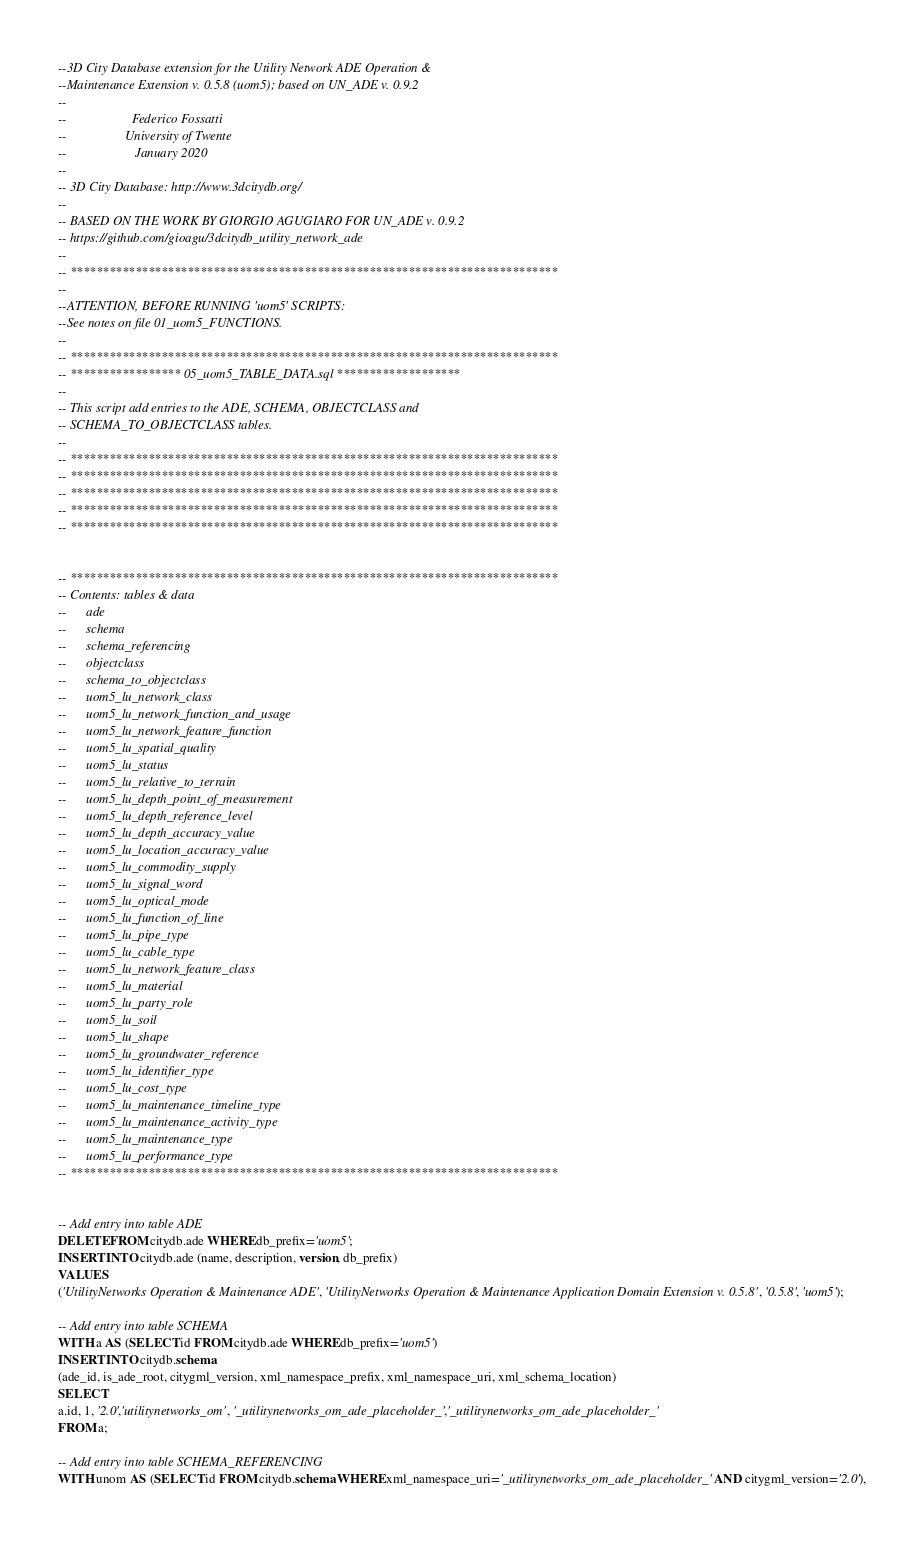Convert code to text. <code><loc_0><loc_0><loc_500><loc_500><_SQL_>--3D City Database extension for the Utility Network ADE Operation & 
--Maintenance Extension v. 0.5.8 (uom5); based on UN_ADE v. 0.9.2
--
--					  Federico Fossatti
--					University of Twente
--                     January 2020
--
-- 3D City Database: http://www.3dcitydb.org/ 
-- 
-- BASED ON THE WORK BY GIORGIO AGUGIARO FOR UN_ADE v. 0.9.2
-- https://github.com/gioagu/3dcitydb_utility_network_ade
--
-- ***************************************************************************
--
--ATTENTION, BEFORE RUNNING 'uom5' SCRIPTS:
--See notes on file 01_uom5_FUNCTIONS.
--
-- ***************************************************************************
-- ***************** 05_uom5_TABLE_DATA.sql *******************
--
-- This script add entries to the ADE, SCHEMA, OBJECTCLASS and
-- SCHEMA_TO_OBJECTCLASS tables.
--
-- ***************************************************************************
-- ***************************************************************************
-- ***************************************************************************
-- ***************************************************************************
-- ***************************************************************************


-- ***************************************************************************
-- Contents: tables & data
-- 		ade
-- 		schema
-- 		schema_referencing
-- 		objectclass
-- 		schema_to_objectclass
-- 		uom5_lu_network_class
-- 		uom5_lu_network_function_and_usage
-- 		uom5_lu_network_feature_function
-- 		uom5_lu_spatial_quality
-- 		uom5_lu_status
-- 		uom5_lu_relative_to_terrain
-- 		uom5_lu_depth_point_of_measurement
-- 		uom5_lu_depth_reference_level
-- 		uom5_lu_depth_accuracy_value
-- 		uom5_lu_location_accuracy_value
-- 		uom5_lu_commodity_supply
-- 		uom5_lu_signal_word
-- 		uom5_lu_optical_mode
-- 		uom5_lu_function_of_line
-- 		uom5_lu_pipe_type
-- 		uom5_lu_cable_type
-- 		uom5_lu_network_feature_class
-- 		uom5_lu_material
-- 		uom5_lu_party_role
-- 		uom5_lu_soil
-- 		uom5_lu_shape
-- 		uom5_lu_groundwater_reference
-- 		uom5_lu_identifier_type
-- 		uom5_lu_cost_type
-- 		uom5_lu_maintenance_timeline_type
-- 		uom5_lu_maintenance_activity_type
-- 		uom5_lu_maintenance_type
-- 		uom5_lu_performance_type
-- ***************************************************************************


-- Add entry into table ADE
DELETE FROM citydb.ade WHERE db_prefix='uom5'; 
INSERT INTO citydb.ade (name, description, version, db_prefix)
VALUES
('UtilityNetworks Operation & Maintenance ADE', 'UtilityNetworks Operation & Maintenance Application Domain Extension v. 0.5.8', '0.5.8', 'uom5');

-- Add entry into table SCHEMA
WITH a AS (SELECT id FROM citydb.ade WHERE db_prefix='uom5')
INSERT INTO citydb.schema
(ade_id, is_ade_root, citygml_version, xml_namespace_prefix, xml_namespace_uri, xml_schema_location)
SELECT
a.id, 1, '2.0','utilitynetworks_om', '_utilitynetworks_om_ade_placeholder_','_utilitynetworks_om_ade_placeholder_'
FROM a;

-- Add entry into table SCHEMA_REFERENCING
WITH unom AS (SELECT id FROM citydb.schema WHERE xml_namespace_uri='_utilitynetworks_om_ade_placeholder_' AND citygml_version='2.0'),</code> 